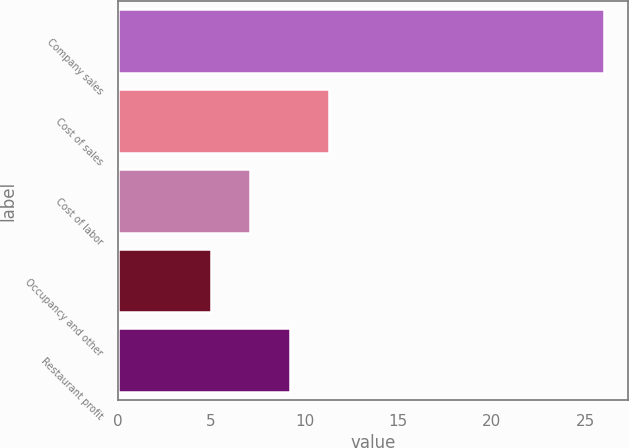Convert chart. <chart><loc_0><loc_0><loc_500><loc_500><bar_chart><fcel>Company sales<fcel>Cost of sales<fcel>Cost of labor<fcel>Occupancy and other<fcel>Restaurant profit<nl><fcel>26<fcel>11.3<fcel>7.1<fcel>5<fcel>9.2<nl></chart> 